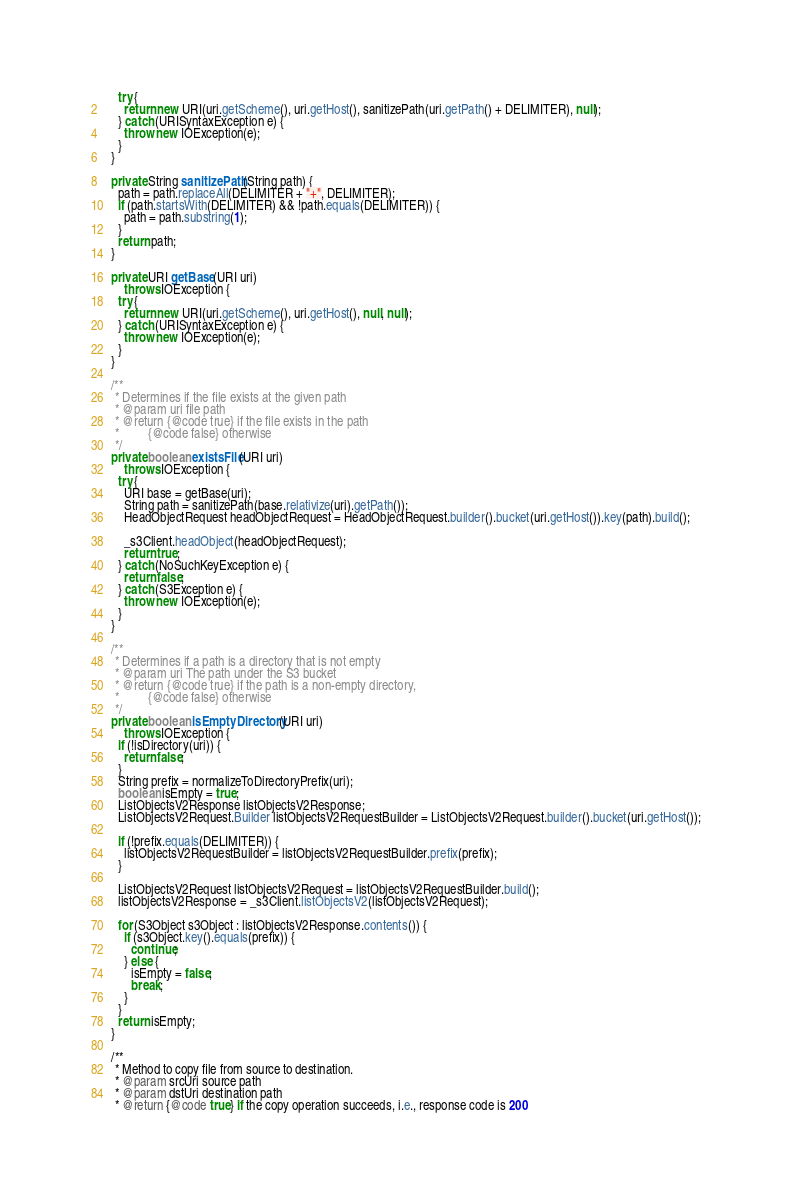Convert code to text. <code><loc_0><loc_0><loc_500><loc_500><_Java_>    try {
      return new URI(uri.getScheme(), uri.getHost(), sanitizePath(uri.getPath() + DELIMITER), null);
    } catch (URISyntaxException e) {
      throw new IOException(e);
    }
  }

  private String sanitizePath(String path) {
    path = path.replaceAll(DELIMITER + "+", DELIMITER);
    if (path.startsWith(DELIMITER) && !path.equals(DELIMITER)) {
      path = path.substring(1);
    }
    return path;
  }

  private URI getBase(URI uri)
      throws IOException {
    try {
      return new URI(uri.getScheme(), uri.getHost(), null, null);
    } catch (URISyntaxException e) {
      throw new IOException(e);
    }
  }

  /**
   * Determines if the file exists at the given path
   * @param uri file path
   * @return {@code true} if the file exists in the path
   *         {@code false} otherwise
   */
  private boolean existsFile(URI uri)
      throws IOException {
    try {
      URI base = getBase(uri);
      String path = sanitizePath(base.relativize(uri).getPath());
      HeadObjectRequest headObjectRequest = HeadObjectRequest.builder().bucket(uri.getHost()).key(path).build();

      _s3Client.headObject(headObjectRequest);
      return true;
    } catch (NoSuchKeyException e) {
      return false;
    } catch (S3Exception e) {
      throw new IOException(e);
    }
  }

  /**
   * Determines if a path is a directory that is not empty
   * @param uri The path under the S3 bucket
   * @return {@code true} if the path is a non-empty directory,
   *         {@code false} otherwise
   */
  private boolean isEmptyDirectory(URI uri)
      throws IOException {
    if (!isDirectory(uri)) {
      return false;
    }
    String prefix = normalizeToDirectoryPrefix(uri);
    boolean isEmpty = true;
    ListObjectsV2Response listObjectsV2Response;
    ListObjectsV2Request.Builder listObjectsV2RequestBuilder = ListObjectsV2Request.builder().bucket(uri.getHost());

    if (!prefix.equals(DELIMITER)) {
      listObjectsV2RequestBuilder = listObjectsV2RequestBuilder.prefix(prefix);
    }

    ListObjectsV2Request listObjectsV2Request = listObjectsV2RequestBuilder.build();
    listObjectsV2Response = _s3Client.listObjectsV2(listObjectsV2Request);

    for (S3Object s3Object : listObjectsV2Response.contents()) {
      if (s3Object.key().equals(prefix)) {
        continue;
      } else {
        isEmpty = false;
        break;
      }
    }
    return isEmpty;
  }

  /**
   * Method to copy file from source to destination.
   * @param srcUri source path
   * @param dstUri destination path
   * @return {@code true} if the copy operation succeeds, i.e., response code is 200</code> 